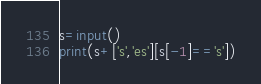Convert code to text. <code><loc_0><loc_0><loc_500><loc_500><_Python_>s=input()
print(s+['s','es'][s[-1]=='s'])</code> 